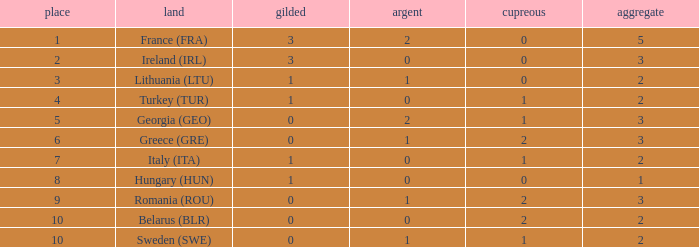What's the total of rank 8 when Silver medals are 0 and gold is more than 1? 0.0. 